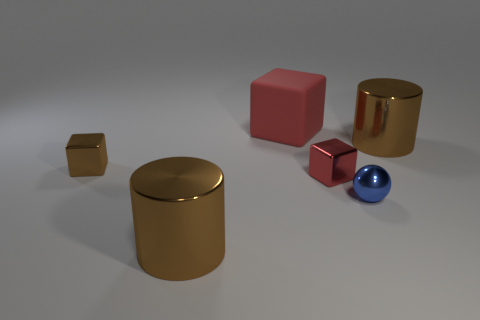What size is the brown shiny thing that is the same shape as the matte object?
Your response must be concise. Small. Is there any other thing that is made of the same material as the blue sphere?
Offer a terse response. Yes. Is the shape of the tiny brown object the same as the big thing right of the red matte block?
Offer a very short reply. No. How many other objects are there of the same size as the blue thing?
Keep it short and to the point. 2. What number of purple things are either large rubber cylinders or small objects?
Give a very brief answer. 0. How many small objects are in front of the tiny red block and left of the sphere?
Keep it short and to the point. 0. What material is the blue ball behind the brown cylinder left of the big brown thing behind the blue shiny ball?
Keep it short and to the point. Metal. How many cubes have the same material as the small blue sphere?
Provide a short and direct response. 2. The other object that is the same color as the matte thing is what shape?
Your answer should be very brief. Cube. What shape is the blue thing that is the same size as the red metallic cube?
Your response must be concise. Sphere. 